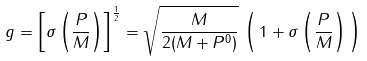<formula> <loc_0><loc_0><loc_500><loc_500>g = \left [ \sigma \left ( \frac { P } { M } \right ) \right ] ^ { \frac { 1 } { 2 } } = \sqrt { \frac { M } { 2 ( M + P ^ { 0 } ) } } \, \left ( \, 1 + \sigma \left ( \frac { P } { M } \right ) \, \right )</formula> 